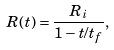Convert formula to latex. <formula><loc_0><loc_0><loc_500><loc_500>R ( t ) = \frac { R _ { i } } { 1 - t / t _ { f } } ,</formula> 